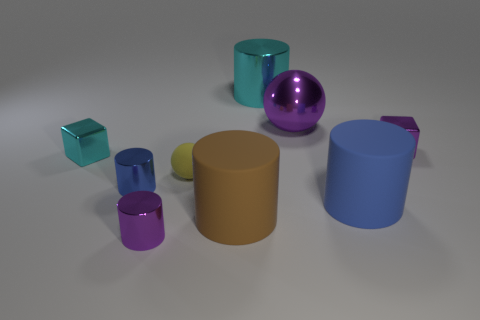Subtract all small purple metal cylinders. How many cylinders are left? 4 Subtract all purple cylinders. How many cylinders are left? 4 Add 1 large brown things. How many objects exist? 10 Subtract all yellow blocks. Subtract all gray spheres. How many blocks are left? 2 Subtract all blue cylinders. How many yellow balls are left? 1 Subtract all purple metal balls. Subtract all purple shiny cubes. How many objects are left? 7 Add 9 big brown things. How many big brown things are left? 10 Add 5 purple cylinders. How many purple cylinders exist? 6 Subtract 1 blue cylinders. How many objects are left? 8 Subtract all spheres. How many objects are left? 7 